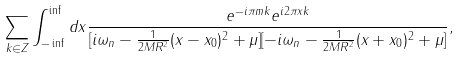Convert formula to latex. <formula><loc_0><loc_0><loc_500><loc_500>\sum _ { k \in Z } \int _ { - \inf } ^ { \inf } d x \frac { e ^ { - i \pi m k } e ^ { i 2 \pi x k } } { [ i \omega _ { n } - \frac { 1 } { 2 M R ^ { 2 } } ( x - x _ { 0 } ) ^ { 2 } + \mu ] [ - i \omega _ { n } - \frac { 1 } { 2 M R ^ { 2 } } ( x + x _ { 0 } ) ^ { 2 } + \mu ] } ,</formula> 